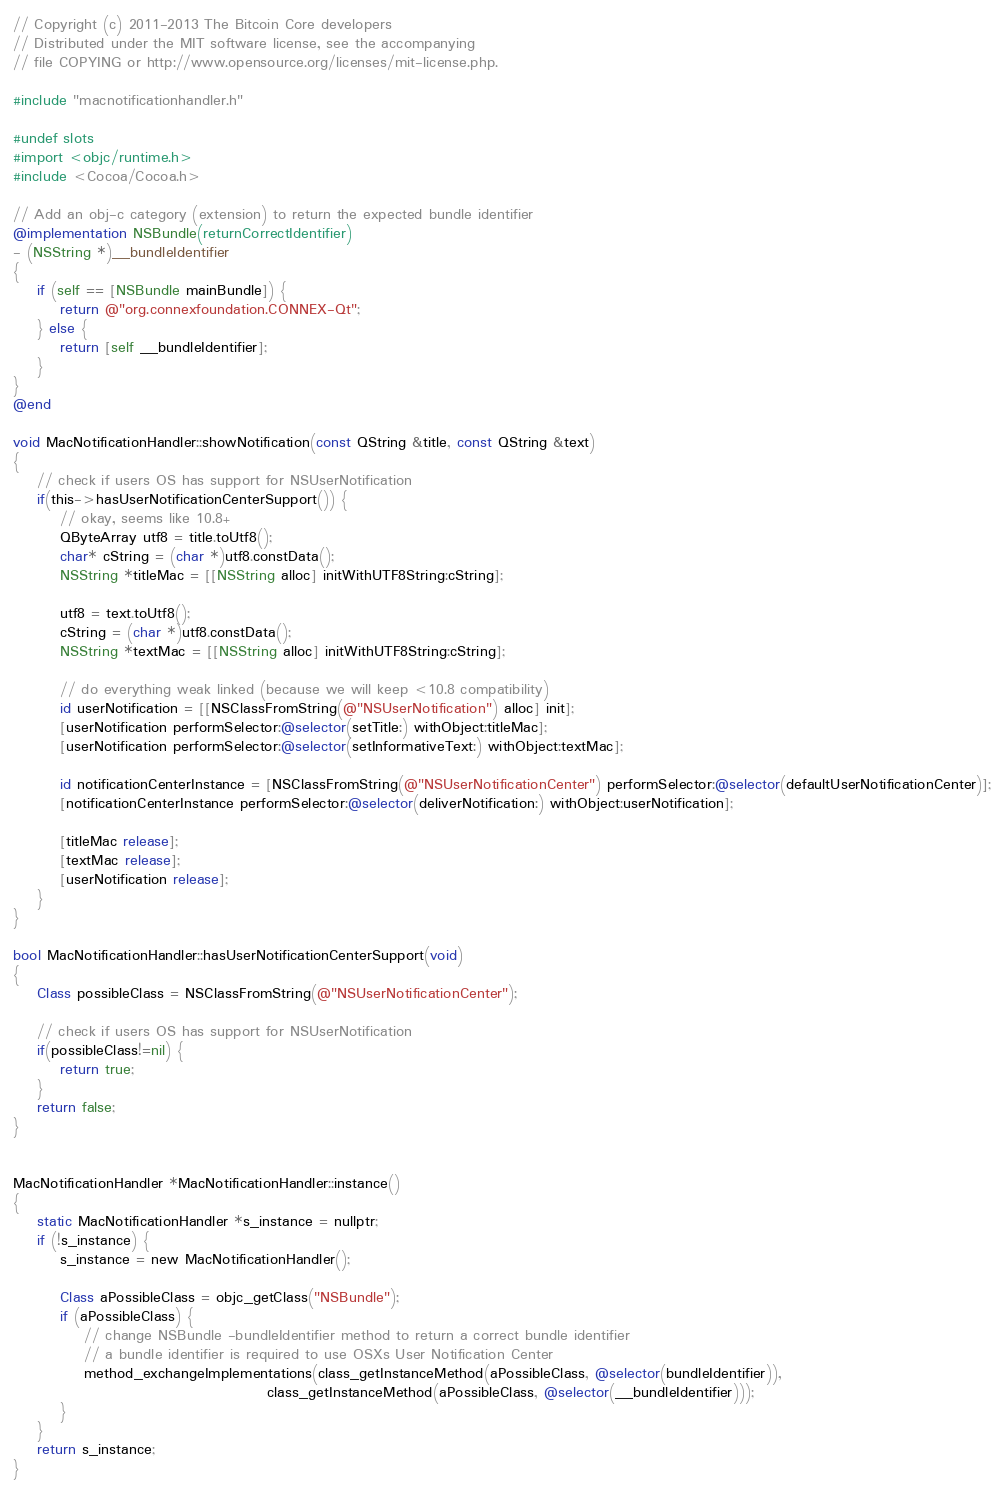Convert code to text. <code><loc_0><loc_0><loc_500><loc_500><_ObjectiveC_>// Copyright (c) 2011-2013 The Bitcoin Core developers
// Distributed under the MIT software license, see the accompanying
// file COPYING or http://www.opensource.org/licenses/mit-license.php.

#include "macnotificationhandler.h"

#undef slots
#import <objc/runtime.h>
#include <Cocoa/Cocoa.h>

// Add an obj-c category (extension) to return the expected bundle identifier
@implementation NSBundle(returnCorrectIdentifier)
- (NSString *)__bundleIdentifier
{
    if (self == [NSBundle mainBundle]) {
        return @"org.connexfoundation.CONNEX-Qt";
    } else {
        return [self __bundleIdentifier];
    }
}
@end

void MacNotificationHandler::showNotification(const QString &title, const QString &text)
{
    // check if users OS has support for NSUserNotification
    if(this->hasUserNotificationCenterSupport()) {
        // okay, seems like 10.8+
        QByteArray utf8 = title.toUtf8();
        char* cString = (char *)utf8.constData();
        NSString *titleMac = [[NSString alloc] initWithUTF8String:cString];

        utf8 = text.toUtf8();
        cString = (char *)utf8.constData();
        NSString *textMac = [[NSString alloc] initWithUTF8String:cString];

        // do everything weak linked (because we will keep <10.8 compatibility)
        id userNotification = [[NSClassFromString(@"NSUserNotification") alloc] init];
        [userNotification performSelector:@selector(setTitle:) withObject:titleMac];
        [userNotification performSelector:@selector(setInformativeText:) withObject:textMac];

        id notificationCenterInstance = [NSClassFromString(@"NSUserNotificationCenter") performSelector:@selector(defaultUserNotificationCenter)];
        [notificationCenterInstance performSelector:@selector(deliverNotification:) withObject:userNotification];

        [titleMac release];
        [textMac release];
        [userNotification release];
    }
}

bool MacNotificationHandler::hasUserNotificationCenterSupport(void)
{
    Class possibleClass = NSClassFromString(@"NSUserNotificationCenter");

    // check if users OS has support for NSUserNotification
    if(possibleClass!=nil) {
        return true;
    }
    return false;
}


MacNotificationHandler *MacNotificationHandler::instance()
{
    static MacNotificationHandler *s_instance = nullptr;
    if (!s_instance) {
        s_instance = new MacNotificationHandler();

        Class aPossibleClass = objc_getClass("NSBundle");
        if (aPossibleClass) {
            // change NSBundle -bundleIdentifier method to return a correct bundle identifier
            // a bundle identifier is required to use OSXs User Notification Center
            method_exchangeImplementations(class_getInstanceMethod(aPossibleClass, @selector(bundleIdentifier)),
                                           class_getInstanceMethod(aPossibleClass, @selector(__bundleIdentifier)));
        }
    }
    return s_instance;
}
</code> 